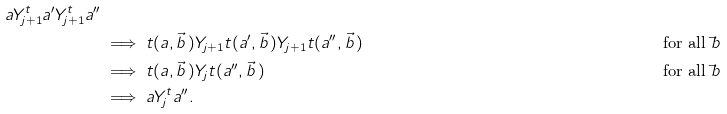Convert formula to latex. <formula><loc_0><loc_0><loc_500><loc_500>a Y ^ { t } _ { j + 1 } a ^ { \prime } Y ^ { t } _ { j + 1 } a ^ { \prime \prime } \\ & \implies t ( a , \vec { b } \, ) Y _ { j + 1 } t ( a ^ { \prime } , \vec { b } \, ) Y _ { j + 1 } t ( a ^ { \prime \prime } , \vec { b } \, ) & & \text {for all $\vec{ }b$} \\ & \implies t ( a , \vec { b } \, ) Y _ { j } t ( a ^ { \prime \prime } , \vec { b } \, ) & & \text {for all $\vec{ }b$} \\ & \implies a Y ^ { t } _ { j } a ^ { \prime \prime } .</formula> 